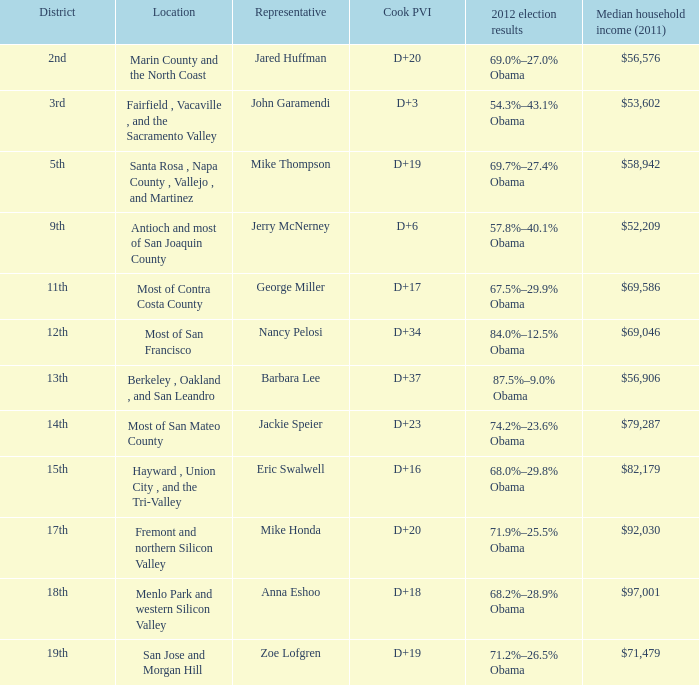What is the cook partisan voting index for the place where mike thompson serves as a representative? D+19. 